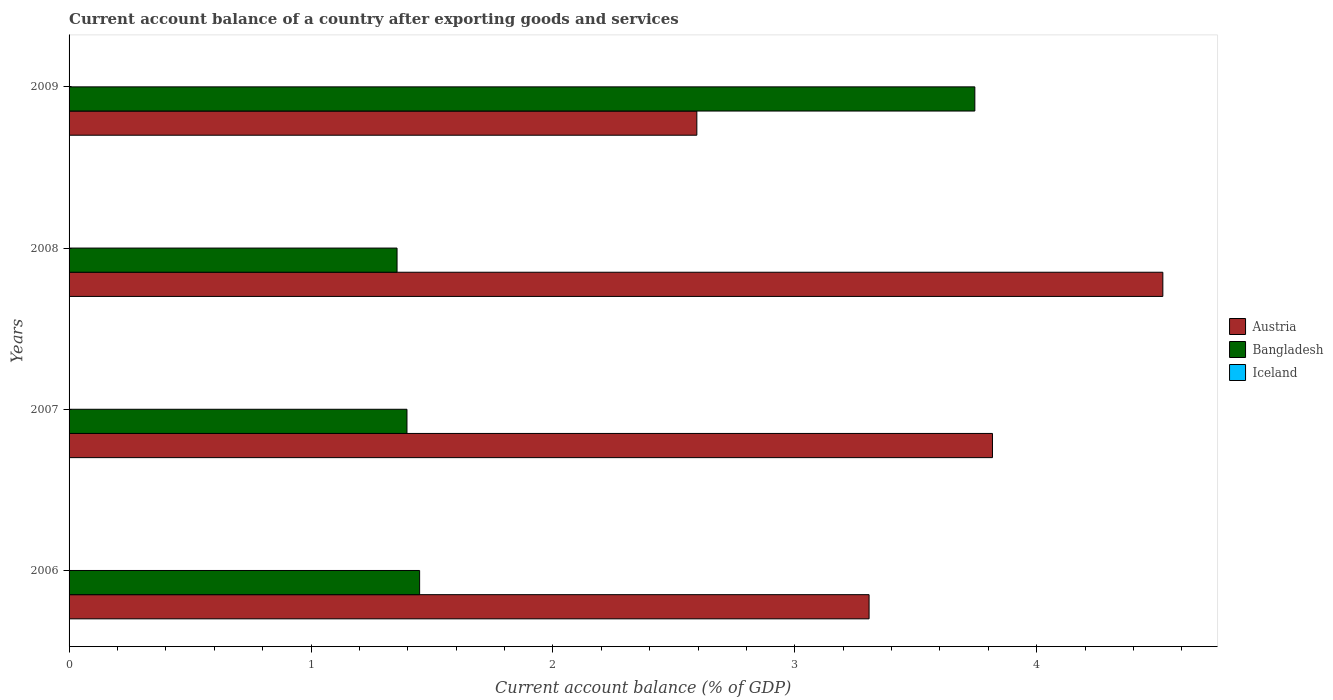How many bars are there on the 4th tick from the bottom?
Your response must be concise. 2. Across all years, what is the maximum account balance in Bangladesh?
Your answer should be very brief. 3.74. What is the difference between the account balance in Bangladesh in 2007 and that in 2008?
Your answer should be compact. 0.04. What is the difference between the account balance in Austria in 2008 and the account balance in Bangladesh in 2007?
Your answer should be compact. 3.12. What is the average account balance in Iceland per year?
Make the answer very short. 0. In the year 2008, what is the difference between the account balance in Bangladesh and account balance in Austria?
Offer a terse response. -3.17. What is the ratio of the account balance in Austria in 2007 to that in 2008?
Your answer should be compact. 0.84. Is the difference between the account balance in Bangladesh in 2006 and 2007 greater than the difference between the account balance in Austria in 2006 and 2007?
Your answer should be very brief. Yes. What is the difference between the highest and the second highest account balance in Bangladesh?
Offer a very short reply. 2.3. What is the difference between the highest and the lowest account balance in Bangladesh?
Your answer should be very brief. 2.39. Is it the case that in every year, the sum of the account balance in Austria and account balance in Bangladesh is greater than the account balance in Iceland?
Offer a terse response. Yes. Are all the bars in the graph horizontal?
Provide a short and direct response. Yes. How many years are there in the graph?
Your response must be concise. 4. What is the difference between two consecutive major ticks on the X-axis?
Provide a succinct answer. 1. Does the graph contain any zero values?
Your response must be concise. Yes. Does the graph contain grids?
Keep it short and to the point. No. How many legend labels are there?
Provide a short and direct response. 3. How are the legend labels stacked?
Keep it short and to the point. Vertical. What is the title of the graph?
Your answer should be compact. Current account balance of a country after exporting goods and services. Does "Namibia" appear as one of the legend labels in the graph?
Offer a terse response. No. What is the label or title of the X-axis?
Provide a short and direct response. Current account balance (% of GDP). What is the label or title of the Y-axis?
Offer a terse response. Years. What is the Current account balance (% of GDP) in Austria in 2006?
Provide a short and direct response. 3.31. What is the Current account balance (% of GDP) in Bangladesh in 2006?
Offer a very short reply. 1.45. What is the Current account balance (% of GDP) in Iceland in 2006?
Offer a terse response. 0. What is the Current account balance (% of GDP) of Austria in 2007?
Offer a terse response. 3.82. What is the Current account balance (% of GDP) in Bangladesh in 2007?
Make the answer very short. 1.4. What is the Current account balance (% of GDP) in Iceland in 2007?
Offer a terse response. 0. What is the Current account balance (% of GDP) in Austria in 2008?
Your answer should be compact. 4.52. What is the Current account balance (% of GDP) in Bangladesh in 2008?
Your answer should be compact. 1.36. What is the Current account balance (% of GDP) of Austria in 2009?
Offer a terse response. 2.59. What is the Current account balance (% of GDP) of Bangladesh in 2009?
Offer a terse response. 3.74. Across all years, what is the maximum Current account balance (% of GDP) of Austria?
Your answer should be compact. 4.52. Across all years, what is the maximum Current account balance (% of GDP) in Bangladesh?
Give a very brief answer. 3.74. Across all years, what is the minimum Current account balance (% of GDP) of Austria?
Your answer should be very brief. 2.59. Across all years, what is the minimum Current account balance (% of GDP) in Bangladesh?
Make the answer very short. 1.36. What is the total Current account balance (% of GDP) in Austria in the graph?
Your answer should be compact. 14.24. What is the total Current account balance (% of GDP) of Bangladesh in the graph?
Offer a very short reply. 7.95. What is the difference between the Current account balance (% of GDP) of Austria in 2006 and that in 2007?
Ensure brevity in your answer.  -0.51. What is the difference between the Current account balance (% of GDP) of Bangladesh in 2006 and that in 2007?
Keep it short and to the point. 0.05. What is the difference between the Current account balance (% of GDP) of Austria in 2006 and that in 2008?
Provide a short and direct response. -1.21. What is the difference between the Current account balance (% of GDP) in Bangladesh in 2006 and that in 2008?
Keep it short and to the point. 0.09. What is the difference between the Current account balance (% of GDP) of Austria in 2006 and that in 2009?
Make the answer very short. 0.71. What is the difference between the Current account balance (% of GDP) of Bangladesh in 2006 and that in 2009?
Your response must be concise. -2.3. What is the difference between the Current account balance (% of GDP) of Austria in 2007 and that in 2008?
Give a very brief answer. -0.7. What is the difference between the Current account balance (% of GDP) of Bangladesh in 2007 and that in 2008?
Offer a terse response. 0.04. What is the difference between the Current account balance (% of GDP) in Austria in 2007 and that in 2009?
Offer a terse response. 1.22. What is the difference between the Current account balance (% of GDP) in Bangladesh in 2007 and that in 2009?
Make the answer very short. -2.35. What is the difference between the Current account balance (% of GDP) of Austria in 2008 and that in 2009?
Keep it short and to the point. 1.93. What is the difference between the Current account balance (% of GDP) of Bangladesh in 2008 and that in 2009?
Your answer should be compact. -2.39. What is the difference between the Current account balance (% of GDP) in Austria in 2006 and the Current account balance (% of GDP) in Bangladesh in 2007?
Your answer should be very brief. 1.91. What is the difference between the Current account balance (% of GDP) in Austria in 2006 and the Current account balance (% of GDP) in Bangladesh in 2008?
Provide a succinct answer. 1.95. What is the difference between the Current account balance (% of GDP) of Austria in 2006 and the Current account balance (% of GDP) of Bangladesh in 2009?
Provide a short and direct response. -0.44. What is the difference between the Current account balance (% of GDP) in Austria in 2007 and the Current account balance (% of GDP) in Bangladesh in 2008?
Offer a very short reply. 2.46. What is the difference between the Current account balance (% of GDP) of Austria in 2007 and the Current account balance (% of GDP) of Bangladesh in 2009?
Provide a short and direct response. 0.07. What is the difference between the Current account balance (% of GDP) in Austria in 2008 and the Current account balance (% of GDP) in Bangladesh in 2009?
Your answer should be compact. 0.78. What is the average Current account balance (% of GDP) in Austria per year?
Ensure brevity in your answer.  3.56. What is the average Current account balance (% of GDP) of Bangladesh per year?
Offer a terse response. 1.99. In the year 2006, what is the difference between the Current account balance (% of GDP) in Austria and Current account balance (% of GDP) in Bangladesh?
Give a very brief answer. 1.86. In the year 2007, what is the difference between the Current account balance (% of GDP) of Austria and Current account balance (% of GDP) of Bangladesh?
Give a very brief answer. 2.42. In the year 2008, what is the difference between the Current account balance (% of GDP) of Austria and Current account balance (% of GDP) of Bangladesh?
Give a very brief answer. 3.17. In the year 2009, what is the difference between the Current account balance (% of GDP) in Austria and Current account balance (% of GDP) in Bangladesh?
Give a very brief answer. -1.15. What is the ratio of the Current account balance (% of GDP) in Austria in 2006 to that in 2007?
Keep it short and to the point. 0.87. What is the ratio of the Current account balance (% of GDP) in Bangladesh in 2006 to that in 2007?
Your answer should be very brief. 1.04. What is the ratio of the Current account balance (% of GDP) of Austria in 2006 to that in 2008?
Offer a terse response. 0.73. What is the ratio of the Current account balance (% of GDP) in Bangladesh in 2006 to that in 2008?
Offer a terse response. 1.07. What is the ratio of the Current account balance (% of GDP) of Austria in 2006 to that in 2009?
Keep it short and to the point. 1.27. What is the ratio of the Current account balance (% of GDP) of Bangladesh in 2006 to that in 2009?
Offer a terse response. 0.39. What is the ratio of the Current account balance (% of GDP) of Austria in 2007 to that in 2008?
Provide a succinct answer. 0.84. What is the ratio of the Current account balance (% of GDP) in Bangladesh in 2007 to that in 2008?
Keep it short and to the point. 1.03. What is the ratio of the Current account balance (% of GDP) of Austria in 2007 to that in 2009?
Your answer should be compact. 1.47. What is the ratio of the Current account balance (% of GDP) in Bangladesh in 2007 to that in 2009?
Your response must be concise. 0.37. What is the ratio of the Current account balance (% of GDP) in Austria in 2008 to that in 2009?
Offer a very short reply. 1.74. What is the ratio of the Current account balance (% of GDP) in Bangladesh in 2008 to that in 2009?
Provide a succinct answer. 0.36. What is the difference between the highest and the second highest Current account balance (% of GDP) of Austria?
Keep it short and to the point. 0.7. What is the difference between the highest and the second highest Current account balance (% of GDP) in Bangladesh?
Provide a short and direct response. 2.3. What is the difference between the highest and the lowest Current account balance (% of GDP) of Austria?
Give a very brief answer. 1.93. What is the difference between the highest and the lowest Current account balance (% of GDP) in Bangladesh?
Keep it short and to the point. 2.39. 